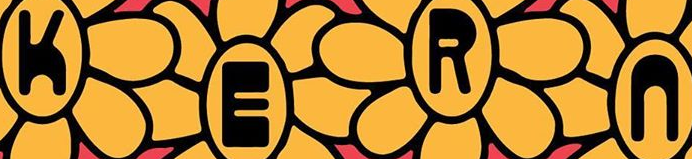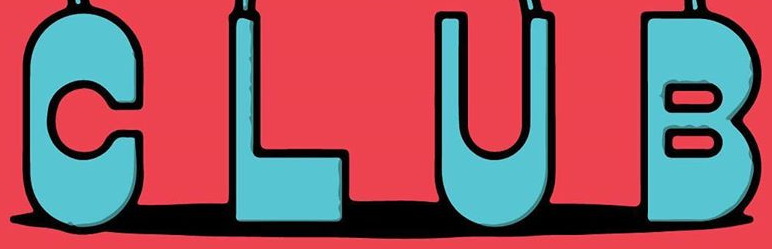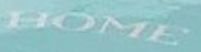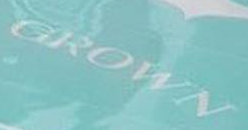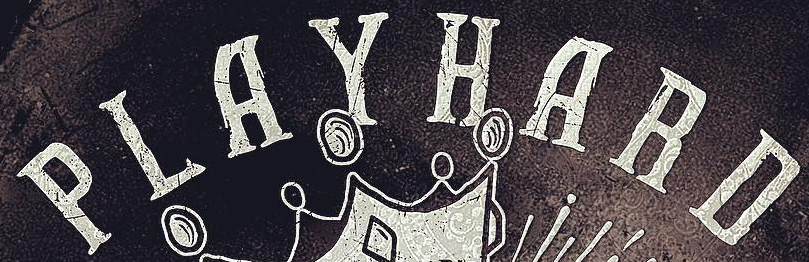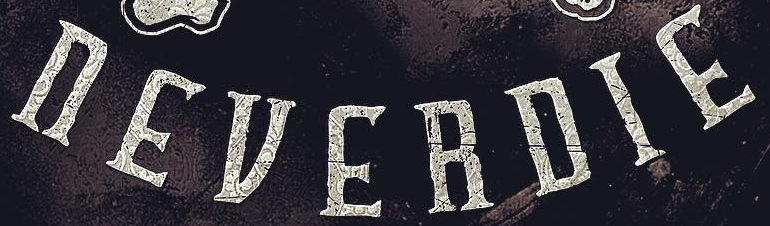What text is displayed in these images sequentially, separated by a semicolon? KERn; CLUB; HOME; GROWN; PLAYHARD; nEVERDIE 